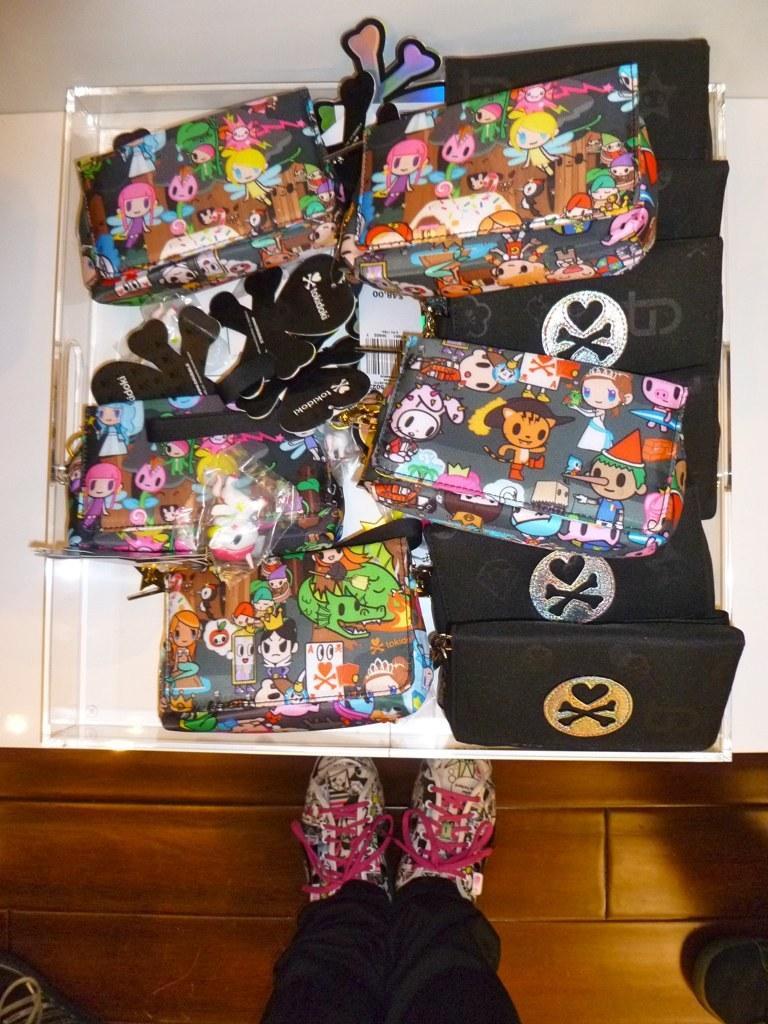Could you give a brief overview of what you see in this image? This is a box of hand bangs on a table. here we can see a hand bag with cartoon pictures on it and a black colour hand bag and we can see shoe of a person standing 